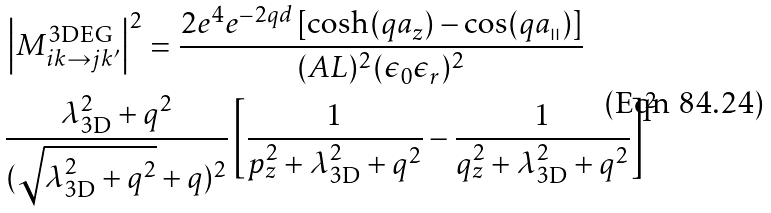<formula> <loc_0><loc_0><loc_500><loc_500>& \left | M ^ { \text {3DEG} } _ { i k \rightarrow j k ^ { \prime } } \right | ^ { 2 } = \frac { 2 e ^ { 4 } e ^ { - 2 q d } \left [ \cosh ( q a _ { z } ) - \cos ( q a _ { \shortparallel } ) \right ] } { ( A L ) ^ { 2 } ( \epsilon _ { 0 } \epsilon _ { r } ) ^ { 2 } } \\ & \frac { \lambda _ { \text {3D} } ^ { 2 } + q ^ { 2 } } { ( \sqrt { \lambda _ { \text {3D} } ^ { 2 } + q ^ { 2 } } + q ) ^ { 2 } } \left [ \frac { 1 } { p _ { z } ^ { 2 } + \lambda _ { \text {3D} } ^ { 2 } + q ^ { 2 } } - \frac { 1 } { q _ { z } ^ { 2 } + \lambda _ { \text {3D} } ^ { 2 } + q ^ { 2 } } \right ] ^ { 2 }</formula> 